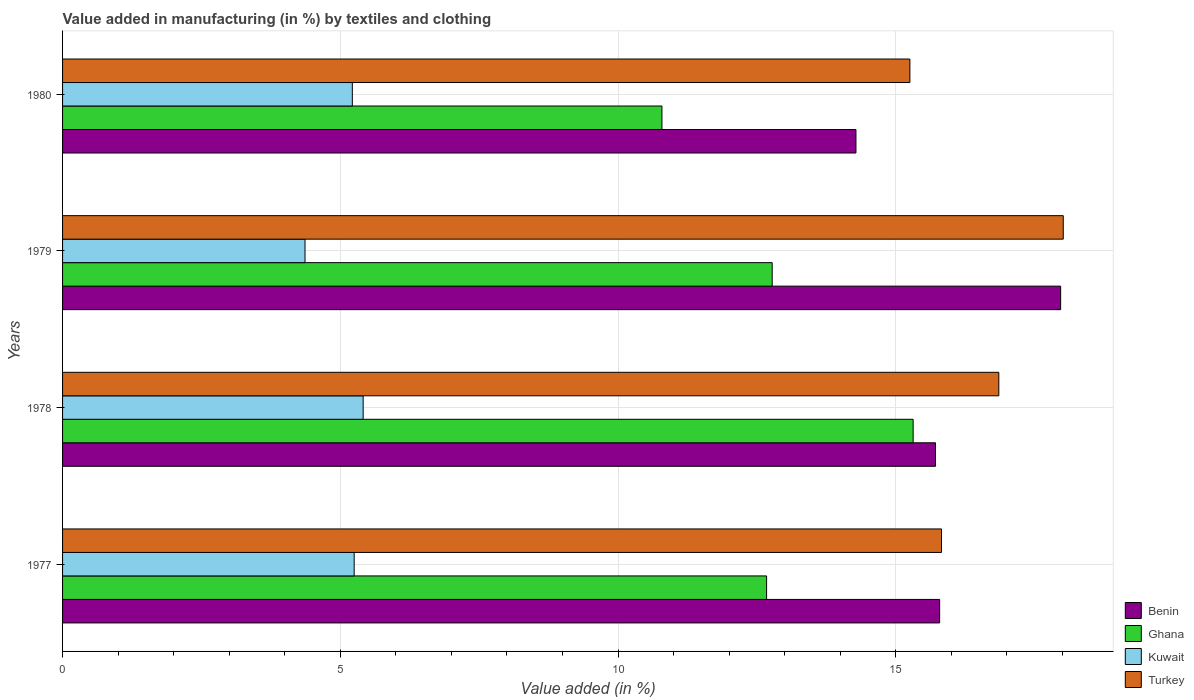How many different coloured bars are there?
Your answer should be compact. 4. How many groups of bars are there?
Your answer should be compact. 4. Are the number of bars per tick equal to the number of legend labels?
Provide a short and direct response. Yes. Are the number of bars on each tick of the Y-axis equal?
Offer a very short reply. Yes. How many bars are there on the 4th tick from the bottom?
Make the answer very short. 4. What is the label of the 3rd group of bars from the top?
Offer a terse response. 1978. What is the percentage of value added in manufacturing by textiles and clothing in Kuwait in 1979?
Your answer should be very brief. 4.37. Across all years, what is the maximum percentage of value added in manufacturing by textiles and clothing in Ghana?
Offer a terse response. 15.31. Across all years, what is the minimum percentage of value added in manufacturing by textiles and clothing in Benin?
Your response must be concise. 14.28. In which year was the percentage of value added in manufacturing by textiles and clothing in Benin maximum?
Offer a terse response. 1979. In which year was the percentage of value added in manufacturing by textiles and clothing in Benin minimum?
Provide a short and direct response. 1980. What is the total percentage of value added in manufacturing by textiles and clothing in Turkey in the graph?
Offer a very short reply. 65.95. What is the difference between the percentage of value added in manufacturing by textiles and clothing in Ghana in 1977 and that in 1978?
Give a very brief answer. -2.64. What is the difference between the percentage of value added in manufacturing by textiles and clothing in Benin in 1979 and the percentage of value added in manufacturing by textiles and clothing in Ghana in 1980?
Keep it short and to the point. 7.18. What is the average percentage of value added in manufacturing by textiles and clothing in Kuwait per year?
Provide a short and direct response. 5.06. In the year 1980, what is the difference between the percentage of value added in manufacturing by textiles and clothing in Turkey and percentage of value added in manufacturing by textiles and clothing in Benin?
Your response must be concise. 0.97. In how many years, is the percentage of value added in manufacturing by textiles and clothing in Ghana greater than 5 %?
Your answer should be very brief. 4. What is the ratio of the percentage of value added in manufacturing by textiles and clothing in Kuwait in 1979 to that in 1980?
Offer a terse response. 0.84. Is the difference between the percentage of value added in manufacturing by textiles and clothing in Turkey in 1978 and 1979 greater than the difference between the percentage of value added in manufacturing by textiles and clothing in Benin in 1978 and 1979?
Offer a very short reply. Yes. What is the difference between the highest and the second highest percentage of value added in manufacturing by textiles and clothing in Kuwait?
Ensure brevity in your answer.  0.16. What is the difference between the highest and the lowest percentage of value added in manufacturing by textiles and clothing in Turkey?
Offer a terse response. 2.76. In how many years, is the percentage of value added in manufacturing by textiles and clothing in Kuwait greater than the average percentage of value added in manufacturing by textiles and clothing in Kuwait taken over all years?
Keep it short and to the point. 3. What does the 4th bar from the top in 1979 represents?
Offer a terse response. Benin. Is it the case that in every year, the sum of the percentage of value added in manufacturing by textiles and clothing in Turkey and percentage of value added in manufacturing by textiles and clothing in Benin is greater than the percentage of value added in manufacturing by textiles and clothing in Ghana?
Keep it short and to the point. Yes. What is the difference between two consecutive major ticks on the X-axis?
Your response must be concise. 5. Are the values on the major ticks of X-axis written in scientific E-notation?
Keep it short and to the point. No. Where does the legend appear in the graph?
Give a very brief answer. Bottom right. How many legend labels are there?
Make the answer very short. 4. What is the title of the graph?
Make the answer very short. Value added in manufacturing (in %) by textiles and clothing. Does "Timor-Leste" appear as one of the legend labels in the graph?
Your answer should be compact. No. What is the label or title of the X-axis?
Offer a very short reply. Value added (in %). What is the Value added (in %) in Benin in 1977?
Your answer should be compact. 15.79. What is the Value added (in %) of Ghana in 1977?
Ensure brevity in your answer.  12.68. What is the Value added (in %) of Kuwait in 1977?
Offer a terse response. 5.25. What is the Value added (in %) in Turkey in 1977?
Give a very brief answer. 15.82. What is the Value added (in %) of Benin in 1978?
Provide a short and direct response. 15.72. What is the Value added (in %) of Ghana in 1978?
Give a very brief answer. 15.31. What is the Value added (in %) in Kuwait in 1978?
Your response must be concise. 5.41. What is the Value added (in %) of Turkey in 1978?
Provide a short and direct response. 16.86. What is the Value added (in %) in Benin in 1979?
Ensure brevity in your answer.  17.97. What is the Value added (in %) in Ghana in 1979?
Your answer should be very brief. 12.78. What is the Value added (in %) of Kuwait in 1979?
Offer a terse response. 4.37. What is the Value added (in %) in Turkey in 1979?
Your answer should be very brief. 18.02. What is the Value added (in %) of Benin in 1980?
Ensure brevity in your answer.  14.28. What is the Value added (in %) in Ghana in 1980?
Make the answer very short. 10.79. What is the Value added (in %) of Kuwait in 1980?
Provide a succinct answer. 5.22. What is the Value added (in %) of Turkey in 1980?
Your answer should be compact. 15.25. Across all years, what is the maximum Value added (in %) of Benin?
Your answer should be compact. 17.97. Across all years, what is the maximum Value added (in %) in Ghana?
Provide a succinct answer. 15.31. Across all years, what is the maximum Value added (in %) of Kuwait?
Make the answer very short. 5.41. Across all years, what is the maximum Value added (in %) in Turkey?
Your response must be concise. 18.02. Across all years, what is the minimum Value added (in %) of Benin?
Make the answer very short. 14.28. Across all years, what is the minimum Value added (in %) of Ghana?
Provide a short and direct response. 10.79. Across all years, what is the minimum Value added (in %) of Kuwait?
Make the answer very short. 4.37. Across all years, what is the minimum Value added (in %) in Turkey?
Offer a very short reply. 15.25. What is the total Value added (in %) of Benin in the graph?
Offer a very short reply. 63.76. What is the total Value added (in %) in Ghana in the graph?
Keep it short and to the point. 51.55. What is the total Value added (in %) in Kuwait in the graph?
Provide a succinct answer. 20.24. What is the total Value added (in %) of Turkey in the graph?
Your answer should be compact. 65.95. What is the difference between the Value added (in %) in Benin in 1977 and that in 1978?
Your answer should be very brief. 0.07. What is the difference between the Value added (in %) in Ghana in 1977 and that in 1978?
Your answer should be compact. -2.64. What is the difference between the Value added (in %) in Kuwait in 1977 and that in 1978?
Your response must be concise. -0.16. What is the difference between the Value added (in %) of Turkey in 1977 and that in 1978?
Offer a very short reply. -1.03. What is the difference between the Value added (in %) of Benin in 1977 and that in 1979?
Offer a terse response. -2.18. What is the difference between the Value added (in %) of Ghana in 1977 and that in 1979?
Make the answer very short. -0.1. What is the difference between the Value added (in %) in Kuwait in 1977 and that in 1979?
Offer a very short reply. 0.88. What is the difference between the Value added (in %) of Turkey in 1977 and that in 1979?
Your response must be concise. -2.19. What is the difference between the Value added (in %) of Benin in 1977 and that in 1980?
Provide a succinct answer. 1.51. What is the difference between the Value added (in %) of Ghana in 1977 and that in 1980?
Keep it short and to the point. 1.88. What is the difference between the Value added (in %) in Kuwait in 1977 and that in 1980?
Your answer should be compact. 0.03. What is the difference between the Value added (in %) in Turkey in 1977 and that in 1980?
Provide a short and direct response. 0.57. What is the difference between the Value added (in %) of Benin in 1978 and that in 1979?
Your answer should be compact. -2.25. What is the difference between the Value added (in %) in Ghana in 1978 and that in 1979?
Provide a succinct answer. 2.54. What is the difference between the Value added (in %) of Kuwait in 1978 and that in 1979?
Your response must be concise. 1.05. What is the difference between the Value added (in %) in Turkey in 1978 and that in 1979?
Give a very brief answer. -1.16. What is the difference between the Value added (in %) of Benin in 1978 and that in 1980?
Make the answer very short. 1.43. What is the difference between the Value added (in %) of Ghana in 1978 and that in 1980?
Ensure brevity in your answer.  4.52. What is the difference between the Value added (in %) in Kuwait in 1978 and that in 1980?
Your response must be concise. 0.2. What is the difference between the Value added (in %) in Turkey in 1978 and that in 1980?
Your answer should be very brief. 1.6. What is the difference between the Value added (in %) in Benin in 1979 and that in 1980?
Provide a succinct answer. 3.69. What is the difference between the Value added (in %) in Ghana in 1979 and that in 1980?
Your response must be concise. 1.98. What is the difference between the Value added (in %) of Kuwait in 1979 and that in 1980?
Your answer should be compact. -0.85. What is the difference between the Value added (in %) in Turkey in 1979 and that in 1980?
Keep it short and to the point. 2.76. What is the difference between the Value added (in %) in Benin in 1977 and the Value added (in %) in Ghana in 1978?
Keep it short and to the point. 0.48. What is the difference between the Value added (in %) of Benin in 1977 and the Value added (in %) of Kuwait in 1978?
Offer a terse response. 10.38. What is the difference between the Value added (in %) in Benin in 1977 and the Value added (in %) in Turkey in 1978?
Keep it short and to the point. -1.07. What is the difference between the Value added (in %) in Ghana in 1977 and the Value added (in %) in Kuwait in 1978?
Make the answer very short. 7.26. What is the difference between the Value added (in %) of Ghana in 1977 and the Value added (in %) of Turkey in 1978?
Ensure brevity in your answer.  -4.18. What is the difference between the Value added (in %) of Kuwait in 1977 and the Value added (in %) of Turkey in 1978?
Provide a succinct answer. -11.61. What is the difference between the Value added (in %) of Benin in 1977 and the Value added (in %) of Ghana in 1979?
Offer a terse response. 3.01. What is the difference between the Value added (in %) in Benin in 1977 and the Value added (in %) in Kuwait in 1979?
Keep it short and to the point. 11.43. What is the difference between the Value added (in %) of Benin in 1977 and the Value added (in %) of Turkey in 1979?
Your answer should be compact. -2.23. What is the difference between the Value added (in %) of Ghana in 1977 and the Value added (in %) of Kuwait in 1979?
Offer a very short reply. 8.31. What is the difference between the Value added (in %) in Ghana in 1977 and the Value added (in %) in Turkey in 1979?
Offer a very short reply. -5.34. What is the difference between the Value added (in %) of Kuwait in 1977 and the Value added (in %) of Turkey in 1979?
Keep it short and to the point. -12.77. What is the difference between the Value added (in %) of Benin in 1977 and the Value added (in %) of Ghana in 1980?
Provide a succinct answer. 5. What is the difference between the Value added (in %) of Benin in 1977 and the Value added (in %) of Kuwait in 1980?
Give a very brief answer. 10.57. What is the difference between the Value added (in %) in Benin in 1977 and the Value added (in %) in Turkey in 1980?
Give a very brief answer. 0.54. What is the difference between the Value added (in %) of Ghana in 1977 and the Value added (in %) of Kuwait in 1980?
Offer a terse response. 7.46. What is the difference between the Value added (in %) of Ghana in 1977 and the Value added (in %) of Turkey in 1980?
Offer a terse response. -2.58. What is the difference between the Value added (in %) of Kuwait in 1977 and the Value added (in %) of Turkey in 1980?
Your response must be concise. -10.01. What is the difference between the Value added (in %) of Benin in 1978 and the Value added (in %) of Ghana in 1979?
Offer a terse response. 2.94. What is the difference between the Value added (in %) in Benin in 1978 and the Value added (in %) in Kuwait in 1979?
Ensure brevity in your answer.  11.35. What is the difference between the Value added (in %) in Benin in 1978 and the Value added (in %) in Turkey in 1979?
Give a very brief answer. -2.3. What is the difference between the Value added (in %) of Ghana in 1978 and the Value added (in %) of Kuwait in 1979?
Your response must be concise. 10.95. What is the difference between the Value added (in %) of Ghana in 1978 and the Value added (in %) of Turkey in 1979?
Your answer should be compact. -2.7. What is the difference between the Value added (in %) of Kuwait in 1978 and the Value added (in %) of Turkey in 1979?
Your answer should be compact. -12.6. What is the difference between the Value added (in %) in Benin in 1978 and the Value added (in %) in Ghana in 1980?
Your answer should be very brief. 4.92. What is the difference between the Value added (in %) in Benin in 1978 and the Value added (in %) in Kuwait in 1980?
Keep it short and to the point. 10.5. What is the difference between the Value added (in %) of Benin in 1978 and the Value added (in %) of Turkey in 1980?
Keep it short and to the point. 0.46. What is the difference between the Value added (in %) of Ghana in 1978 and the Value added (in %) of Kuwait in 1980?
Your answer should be compact. 10.1. What is the difference between the Value added (in %) in Ghana in 1978 and the Value added (in %) in Turkey in 1980?
Ensure brevity in your answer.  0.06. What is the difference between the Value added (in %) of Kuwait in 1978 and the Value added (in %) of Turkey in 1980?
Keep it short and to the point. -9.84. What is the difference between the Value added (in %) in Benin in 1979 and the Value added (in %) in Ghana in 1980?
Provide a short and direct response. 7.18. What is the difference between the Value added (in %) of Benin in 1979 and the Value added (in %) of Kuwait in 1980?
Provide a succinct answer. 12.75. What is the difference between the Value added (in %) of Benin in 1979 and the Value added (in %) of Turkey in 1980?
Your response must be concise. 2.71. What is the difference between the Value added (in %) in Ghana in 1979 and the Value added (in %) in Kuwait in 1980?
Your response must be concise. 7.56. What is the difference between the Value added (in %) in Ghana in 1979 and the Value added (in %) in Turkey in 1980?
Ensure brevity in your answer.  -2.48. What is the difference between the Value added (in %) in Kuwait in 1979 and the Value added (in %) in Turkey in 1980?
Provide a short and direct response. -10.89. What is the average Value added (in %) in Benin per year?
Your answer should be very brief. 15.94. What is the average Value added (in %) in Ghana per year?
Provide a succinct answer. 12.89. What is the average Value added (in %) of Kuwait per year?
Ensure brevity in your answer.  5.06. What is the average Value added (in %) of Turkey per year?
Give a very brief answer. 16.49. In the year 1977, what is the difference between the Value added (in %) of Benin and Value added (in %) of Ghana?
Provide a succinct answer. 3.12. In the year 1977, what is the difference between the Value added (in %) in Benin and Value added (in %) in Kuwait?
Your answer should be very brief. 10.54. In the year 1977, what is the difference between the Value added (in %) in Benin and Value added (in %) in Turkey?
Give a very brief answer. -0.03. In the year 1977, what is the difference between the Value added (in %) in Ghana and Value added (in %) in Kuwait?
Make the answer very short. 7.43. In the year 1977, what is the difference between the Value added (in %) of Ghana and Value added (in %) of Turkey?
Your response must be concise. -3.15. In the year 1977, what is the difference between the Value added (in %) of Kuwait and Value added (in %) of Turkey?
Ensure brevity in your answer.  -10.57. In the year 1978, what is the difference between the Value added (in %) of Benin and Value added (in %) of Ghana?
Your response must be concise. 0.4. In the year 1978, what is the difference between the Value added (in %) in Benin and Value added (in %) in Kuwait?
Provide a short and direct response. 10.3. In the year 1978, what is the difference between the Value added (in %) in Benin and Value added (in %) in Turkey?
Your response must be concise. -1.14. In the year 1978, what is the difference between the Value added (in %) in Ghana and Value added (in %) in Kuwait?
Provide a succinct answer. 9.9. In the year 1978, what is the difference between the Value added (in %) of Ghana and Value added (in %) of Turkey?
Keep it short and to the point. -1.54. In the year 1978, what is the difference between the Value added (in %) in Kuwait and Value added (in %) in Turkey?
Give a very brief answer. -11.44. In the year 1979, what is the difference between the Value added (in %) in Benin and Value added (in %) in Ghana?
Keep it short and to the point. 5.19. In the year 1979, what is the difference between the Value added (in %) of Benin and Value added (in %) of Kuwait?
Give a very brief answer. 13.6. In the year 1979, what is the difference between the Value added (in %) in Benin and Value added (in %) in Turkey?
Provide a succinct answer. -0.05. In the year 1979, what is the difference between the Value added (in %) in Ghana and Value added (in %) in Kuwait?
Make the answer very short. 8.41. In the year 1979, what is the difference between the Value added (in %) in Ghana and Value added (in %) in Turkey?
Ensure brevity in your answer.  -5.24. In the year 1979, what is the difference between the Value added (in %) in Kuwait and Value added (in %) in Turkey?
Your answer should be very brief. -13.65. In the year 1980, what is the difference between the Value added (in %) of Benin and Value added (in %) of Ghana?
Your answer should be compact. 3.49. In the year 1980, what is the difference between the Value added (in %) of Benin and Value added (in %) of Kuwait?
Provide a succinct answer. 9.07. In the year 1980, what is the difference between the Value added (in %) in Benin and Value added (in %) in Turkey?
Your answer should be compact. -0.97. In the year 1980, what is the difference between the Value added (in %) of Ghana and Value added (in %) of Kuwait?
Your answer should be very brief. 5.57. In the year 1980, what is the difference between the Value added (in %) of Ghana and Value added (in %) of Turkey?
Offer a terse response. -4.46. In the year 1980, what is the difference between the Value added (in %) of Kuwait and Value added (in %) of Turkey?
Your answer should be compact. -10.04. What is the ratio of the Value added (in %) of Ghana in 1977 to that in 1978?
Keep it short and to the point. 0.83. What is the ratio of the Value added (in %) of Kuwait in 1977 to that in 1978?
Provide a succinct answer. 0.97. What is the ratio of the Value added (in %) in Turkey in 1977 to that in 1978?
Ensure brevity in your answer.  0.94. What is the ratio of the Value added (in %) in Benin in 1977 to that in 1979?
Ensure brevity in your answer.  0.88. What is the ratio of the Value added (in %) of Ghana in 1977 to that in 1979?
Your answer should be very brief. 0.99. What is the ratio of the Value added (in %) of Kuwait in 1977 to that in 1979?
Keep it short and to the point. 1.2. What is the ratio of the Value added (in %) of Turkey in 1977 to that in 1979?
Make the answer very short. 0.88. What is the ratio of the Value added (in %) in Benin in 1977 to that in 1980?
Ensure brevity in your answer.  1.11. What is the ratio of the Value added (in %) of Ghana in 1977 to that in 1980?
Your answer should be very brief. 1.17. What is the ratio of the Value added (in %) in Kuwait in 1977 to that in 1980?
Provide a short and direct response. 1.01. What is the ratio of the Value added (in %) of Turkey in 1977 to that in 1980?
Your answer should be compact. 1.04. What is the ratio of the Value added (in %) of Benin in 1978 to that in 1979?
Your answer should be compact. 0.87. What is the ratio of the Value added (in %) of Ghana in 1978 to that in 1979?
Keep it short and to the point. 1.2. What is the ratio of the Value added (in %) in Kuwait in 1978 to that in 1979?
Your response must be concise. 1.24. What is the ratio of the Value added (in %) in Turkey in 1978 to that in 1979?
Your answer should be compact. 0.94. What is the ratio of the Value added (in %) in Benin in 1978 to that in 1980?
Your answer should be very brief. 1.1. What is the ratio of the Value added (in %) in Ghana in 1978 to that in 1980?
Make the answer very short. 1.42. What is the ratio of the Value added (in %) of Kuwait in 1978 to that in 1980?
Ensure brevity in your answer.  1.04. What is the ratio of the Value added (in %) of Turkey in 1978 to that in 1980?
Offer a very short reply. 1.1. What is the ratio of the Value added (in %) in Benin in 1979 to that in 1980?
Your answer should be compact. 1.26. What is the ratio of the Value added (in %) of Ghana in 1979 to that in 1980?
Keep it short and to the point. 1.18. What is the ratio of the Value added (in %) of Kuwait in 1979 to that in 1980?
Your response must be concise. 0.84. What is the ratio of the Value added (in %) of Turkey in 1979 to that in 1980?
Provide a succinct answer. 1.18. What is the difference between the highest and the second highest Value added (in %) of Benin?
Your answer should be compact. 2.18. What is the difference between the highest and the second highest Value added (in %) of Ghana?
Your answer should be compact. 2.54. What is the difference between the highest and the second highest Value added (in %) in Kuwait?
Give a very brief answer. 0.16. What is the difference between the highest and the second highest Value added (in %) in Turkey?
Ensure brevity in your answer.  1.16. What is the difference between the highest and the lowest Value added (in %) in Benin?
Offer a very short reply. 3.69. What is the difference between the highest and the lowest Value added (in %) in Ghana?
Provide a succinct answer. 4.52. What is the difference between the highest and the lowest Value added (in %) of Kuwait?
Your answer should be compact. 1.05. What is the difference between the highest and the lowest Value added (in %) in Turkey?
Keep it short and to the point. 2.76. 